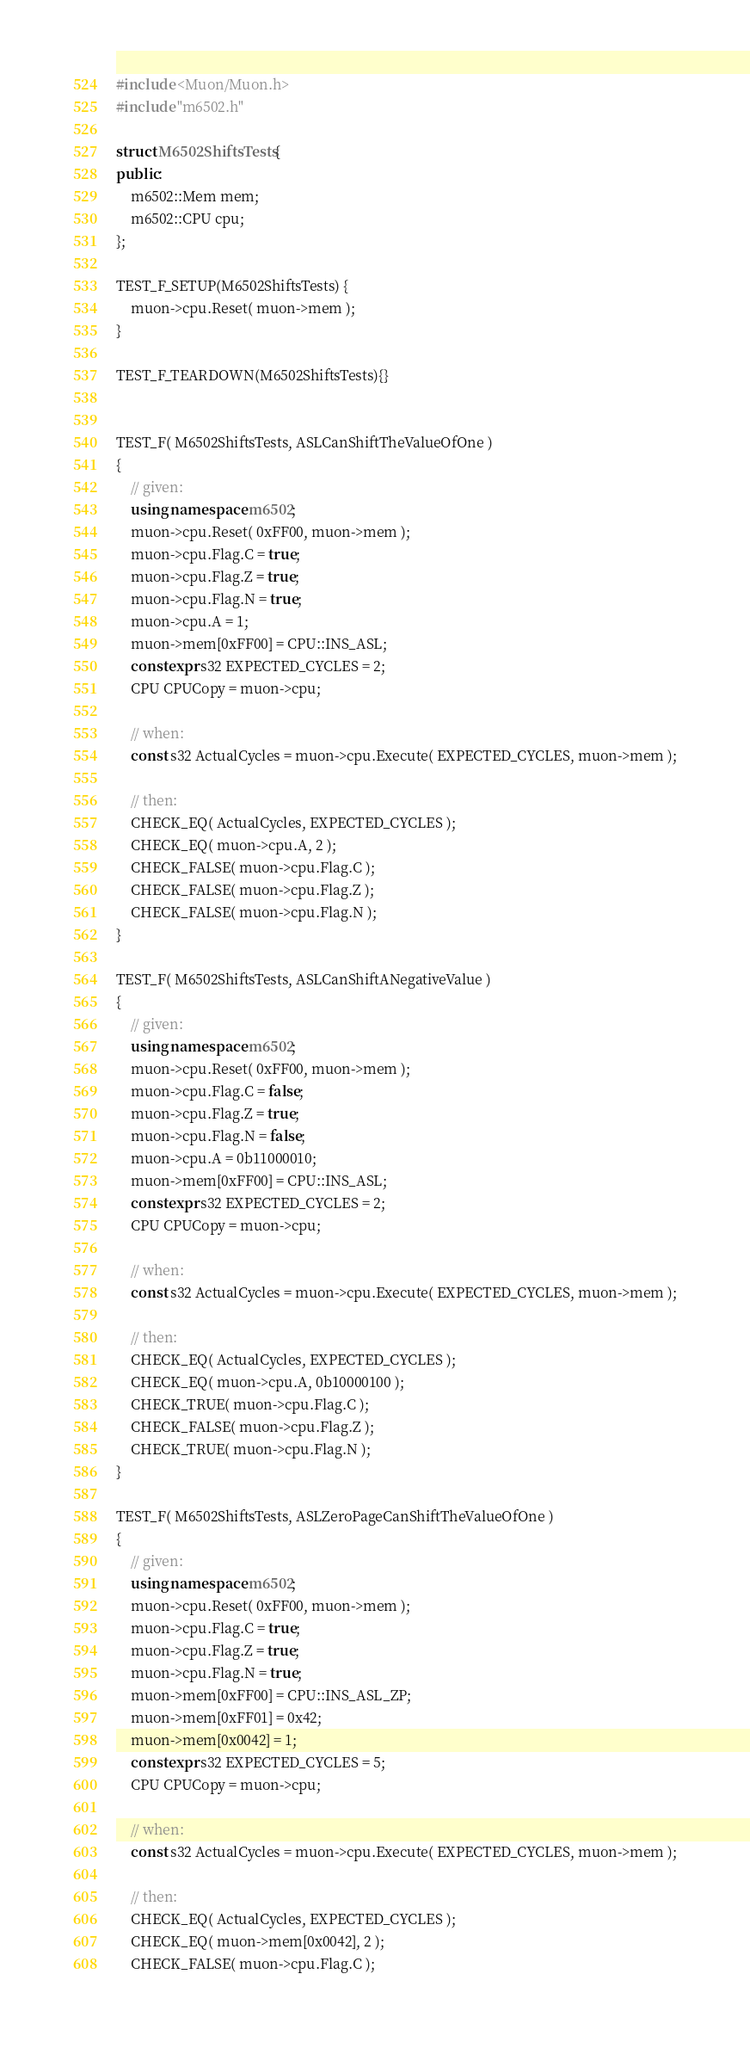Convert code to text. <code><loc_0><loc_0><loc_500><loc_500><_C++_>#include <Muon/Muon.h>
#include "m6502.h"

struct M6502ShiftsTests {
public:
	m6502::Mem mem;
	m6502::CPU cpu;
};

TEST_F_SETUP(M6502ShiftsTests) {
	muon->cpu.Reset( muon->mem );
}

TEST_F_TEARDOWN(M6502ShiftsTests){}


TEST_F( M6502ShiftsTests, ASLCanShiftTheValueOfOne )
{
	// given:
	using namespace m6502;
	muon->cpu.Reset( 0xFF00, muon->mem );
	muon->cpu.Flag.C = true;
	muon->cpu.Flag.Z = true;
	muon->cpu.Flag.N = true;
	muon->cpu.A = 1;
	muon->mem[0xFF00] = CPU::INS_ASL;
	constexpr s32 EXPECTED_CYCLES = 2;
	CPU CPUCopy = muon->cpu;

	// when:
	const s32 ActualCycles = muon->cpu.Execute( EXPECTED_CYCLES, muon->mem );

	// then:
	CHECK_EQ( ActualCycles, EXPECTED_CYCLES );
	CHECK_EQ( muon->cpu.A, 2 );
	CHECK_FALSE( muon->cpu.Flag.C );
	CHECK_FALSE( muon->cpu.Flag.Z );
	CHECK_FALSE( muon->cpu.Flag.N );	
}

TEST_F( M6502ShiftsTests, ASLCanShiftANegativeValue )
{
	// given:
	using namespace m6502;
	muon->cpu.Reset( 0xFF00, muon->mem );
	muon->cpu.Flag.C = false;
	muon->cpu.Flag.Z = true;
	muon->cpu.Flag.N = false;
	muon->cpu.A = 0b11000010;
	muon->mem[0xFF00] = CPU::INS_ASL;
	constexpr s32 EXPECTED_CYCLES = 2;
	CPU CPUCopy = muon->cpu;

	// when:
	const s32 ActualCycles = muon->cpu.Execute( EXPECTED_CYCLES, muon->mem );

	// then:
	CHECK_EQ( ActualCycles, EXPECTED_CYCLES );
	CHECK_EQ( muon->cpu.A, 0b10000100 );
	CHECK_TRUE( muon->cpu.Flag.C );
	CHECK_FALSE( muon->cpu.Flag.Z );
	CHECK_TRUE( muon->cpu.Flag.N );
}

TEST_F( M6502ShiftsTests, ASLZeroPageCanShiftTheValueOfOne )
{
	// given:
	using namespace m6502;
	muon->cpu.Reset( 0xFF00, muon->mem );
	muon->cpu.Flag.C = true;
	muon->cpu.Flag.Z = true;
	muon->cpu.Flag.N = true;
	muon->mem[0xFF00] = CPU::INS_ASL_ZP;
	muon->mem[0xFF01] = 0x42;
	muon->mem[0x0042] = 1;
	constexpr s32 EXPECTED_CYCLES = 5;
	CPU CPUCopy = muon->cpu;

	// when:
	const s32 ActualCycles = muon->cpu.Execute( EXPECTED_CYCLES, muon->mem );

	// then:
	CHECK_EQ( ActualCycles, EXPECTED_CYCLES );
	CHECK_EQ( muon->mem[0x0042], 2 );
	CHECK_FALSE( muon->cpu.Flag.C );</code> 